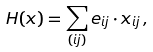Convert formula to latex. <formula><loc_0><loc_0><loc_500><loc_500>H ( { x } ) = \sum _ { ( i j ) } e _ { i j } \cdot x _ { i j } \, ,</formula> 